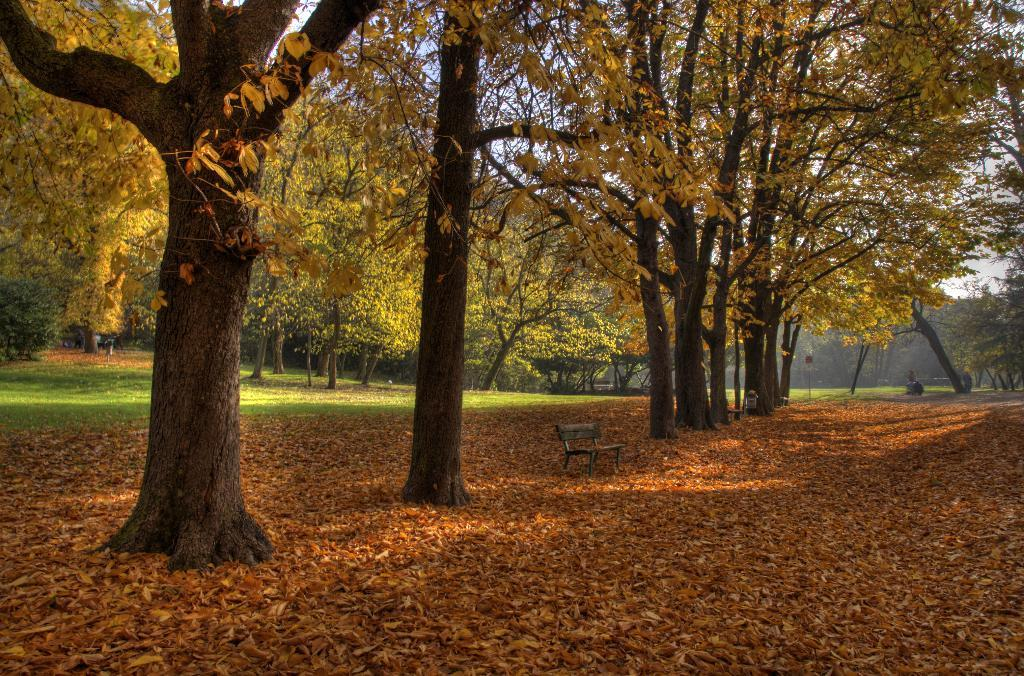What type of vegetation can be seen in the image? There are trees in the image. What can be found on the trees in the image? There are leaves in the image. What type of seating is present in the image? There is a bench in the image. What else can be found on the ground in the image? There are other objects on the ground in the image. What is visible in the background of the image? The sky is visible in the background of the image. What type of hat is worn by the tree in the image? There is no hat present in the image; it features trees, leaves, a bench, and other objects on the ground. What effect does the hat have on the tree's ability to grow leaves in the image? There is no hat present in the image, so it cannot have any effect on the tree's ability to grow leaves. 